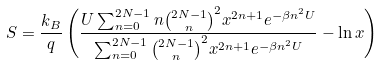Convert formula to latex. <formula><loc_0><loc_0><loc_500><loc_500>S = \frac { k _ { B } } { q } \left ( \frac { U \sum _ { n = 0 } ^ { 2 N - 1 } n { 2 N - 1 \choose n } ^ { 2 } x ^ { 2 n + 1 } e ^ { - \beta n ^ { 2 } U } } { \sum _ { n = 0 } ^ { 2 N - 1 } { 2 N - 1 \choose n } ^ { 2 } x ^ { 2 n + 1 } e ^ { - \beta n ^ { 2 } U } } - \ln x \right )</formula> 